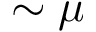Convert formula to latex. <formula><loc_0><loc_0><loc_500><loc_500>\sim \mu</formula> 